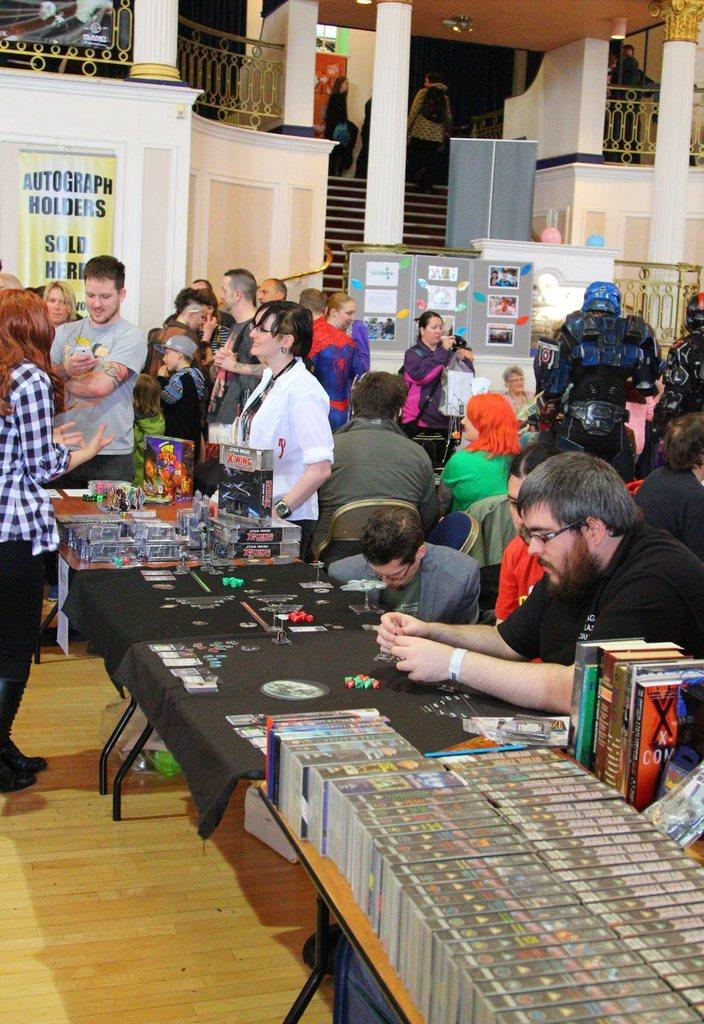What are the people in the image doing? People are sitting on chairs in the image. What can be seen on the table in the image? There are books and other objects on the table in the image. What are the people near the table doing? People are standing near the table in the image. What is visible in the background of the image? There is a building in the background of the image. What is hanging on the wall in the image? There is a poster visible in the image. What type of pizzas are being served at the seashore in the image? There is no seashore or pizzas present in the image. 